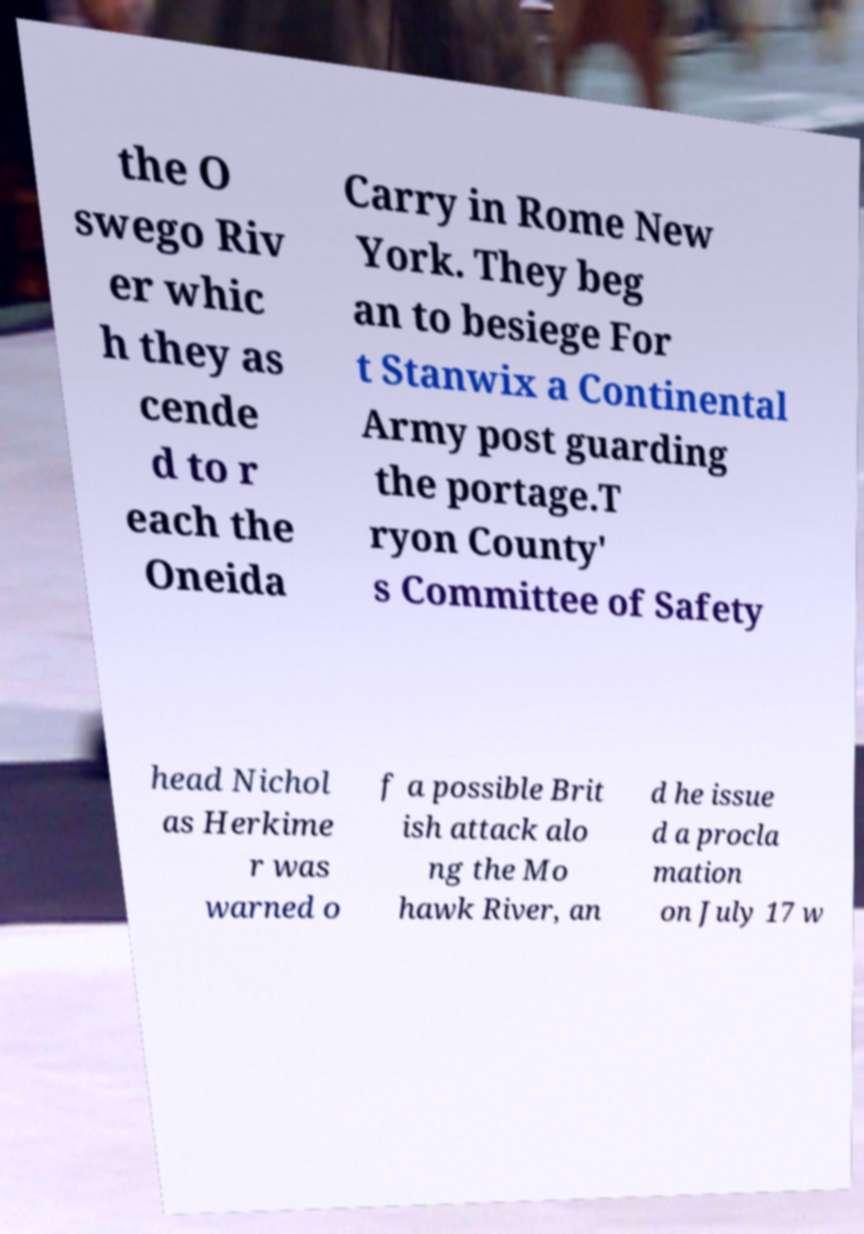What messages or text are displayed in this image? I need them in a readable, typed format. the O swego Riv er whic h they as cende d to r each the Oneida Carry in Rome New York. They beg an to besiege For t Stanwix a Continental Army post guarding the portage.T ryon County' s Committee of Safety head Nichol as Herkime r was warned o f a possible Brit ish attack alo ng the Mo hawk River, an d he issue d a procla mation on July 17 w 